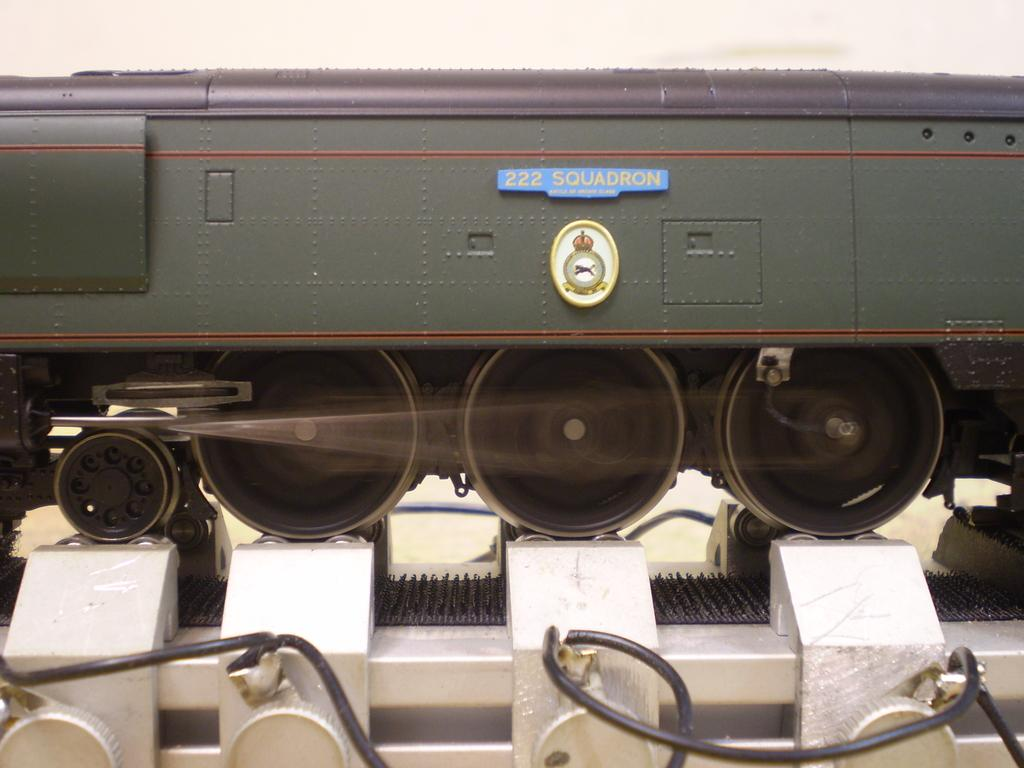What is the main subject of the image? There is an object in the image that resembles a train. Can you describe any specific features of the train-like object? Yes, there is text visible on the object. What type of material is at the bottom of the image? There is a metal at the bottom of the image. What is located at the top of the image? There is a wall at the top of the image. What type of trousers can be seen hanging on the wall in the image? There are no trousers present in the image; the wall is part of the background and does not have any clothing hanging on it. How many parcels are visible in the image? There are no parcels present in the image; the main subject is the train-like object with text on it. 